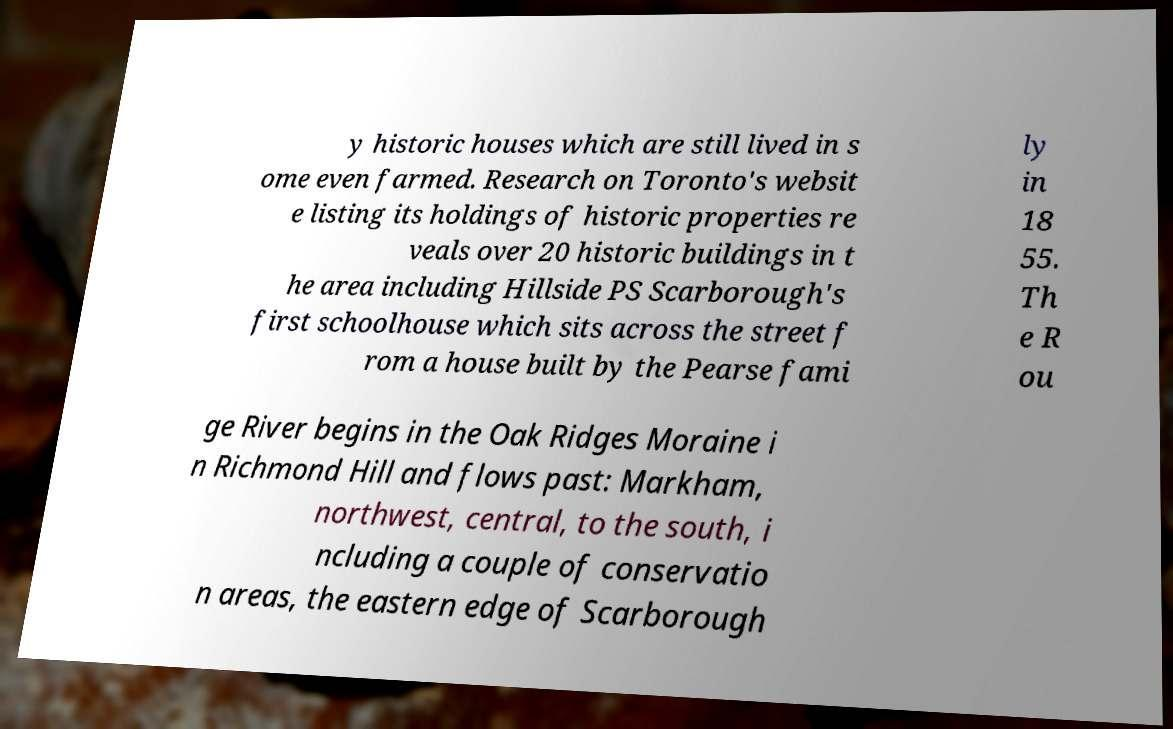Could you extract and type out the text from this image? y historic houses which are still lived in s ome even farmed. Research on Toronto's websit e listing its holdings of historic properties re veals over 20 historic buildings in t he area including Hillside PS Scarborough's first schoolhouse which sits across the street f rom a house built by the Pearse fami ly in 18 55. Th e R ou ge River begins in the Oak Ridges Moraine i n Richmond Hill and flows past: Markham, northwest, central, to the south, i ncluding a couple of conservatio n areas, the eastern edge of Scarborough 